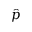Convert formula to latex. <formula><loc_0><loc_0><loc_500><loc_500>\hat { p }</formula> 